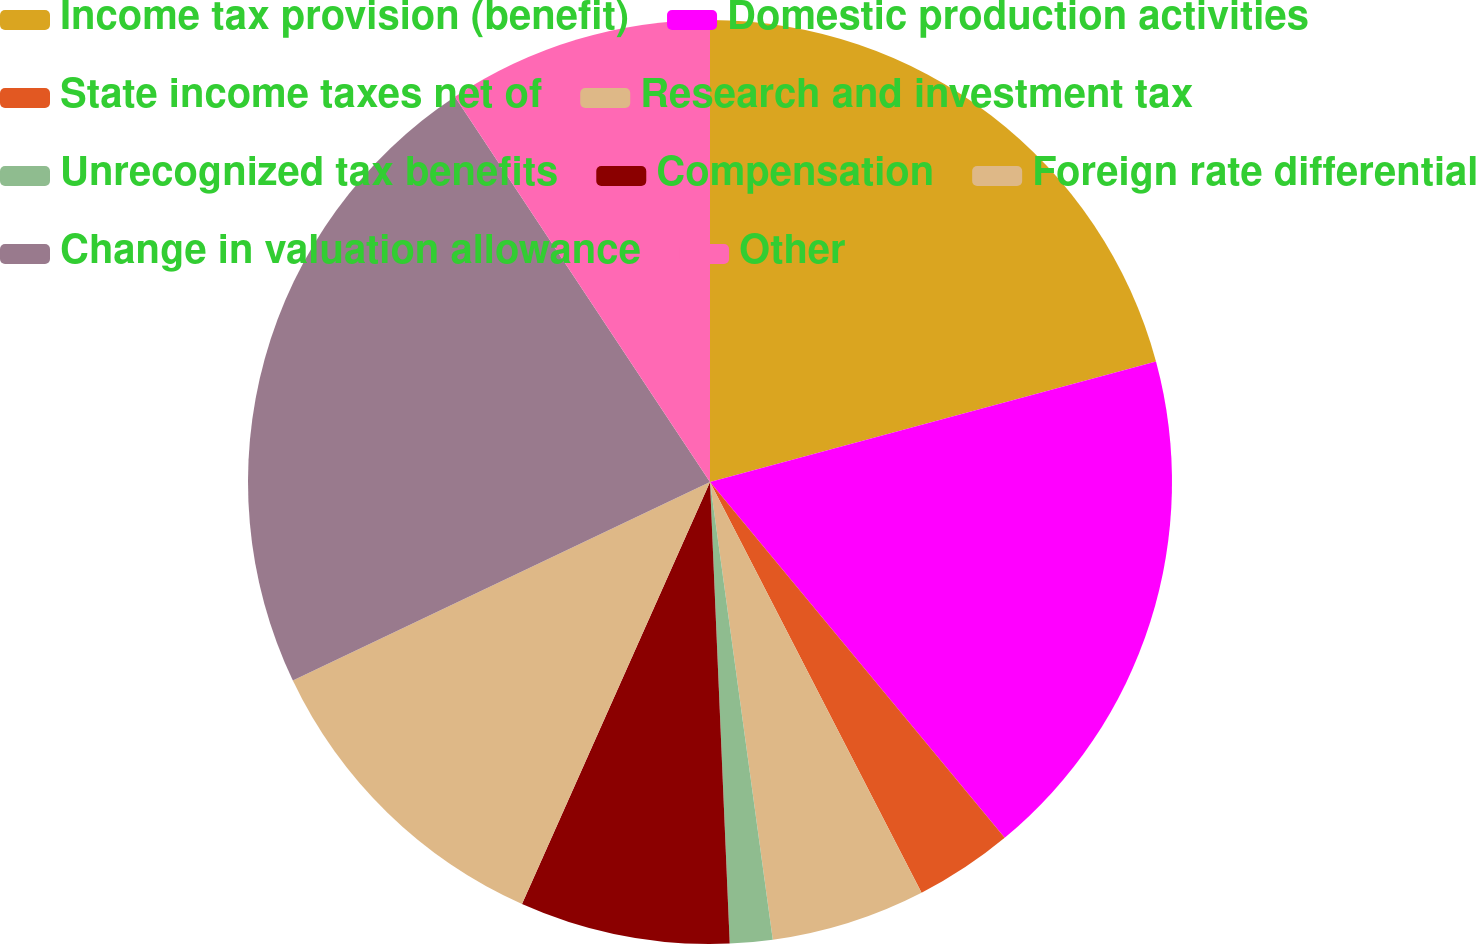Convert chart to OTSL. <chart><loc_0><loc_0><loc_500><loc_500><pie_chart><fcel>Income tax provision (benefit)<fcel>Domestic production activities<fcel>State income taxes net of<fcel>Research and investment tax<fcel>Unrecognized tax benefits<fcel>Compensation<fcel>Foreign rate differential<fcel>Change in valuation allowance<fcel>Other<nl><fcel>20.8%<fcel>18.19%<fcel>3.44%<fcel>5.4%<fcel>1.49%<fcel>7.35%<fcel>11.26%<fcel>22.76%<fcel>9.31%<nl></chart> 